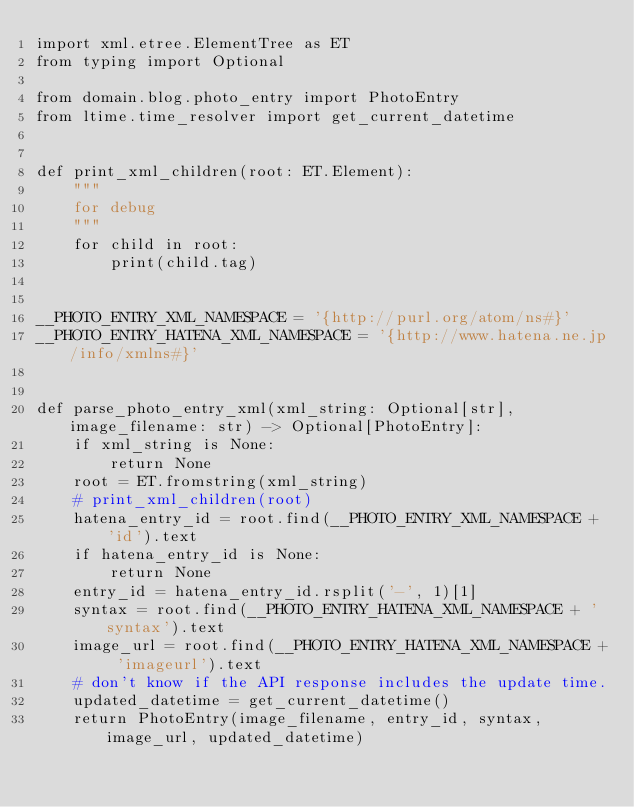Convert code to text. <code><loc_0><loc_0><loc_500><loc_500><_Python_>import xml.etree.ElementTree as ET
from typing import Optional

from domain.blog.photo_entry import PhotoEntry
from ltime.time_resolver import get_current_datetime


def print_xml_children(root: ET.Element):
    """
    for debug
    """
    for child in root:
        print(child.tag)


__PHOTO_ENTRY_XML_NAMESPACE = '{http://purl.org/atom/ns#}'
__PHOTO_ENTRY_HATENA_XML_NAMESPACE = '{http://www.hatena.ne.jp/info/xmlns#}'


def parse_photo_entry_xml(xml_string: Optional[str], image_filename: str) -> Optional[PhotoEntry]:
    if xml_string is None:
        return None
    root = ET.fromstring(xml_string)
    # print_xml_children(root)
    hatena_entry_id = root.find(__PHOTO_ENTRY_XML_NAMESPACE + 'id').text
    if hatena_entry_id is None:
        return None
    entry_id = hatena_entry_id.rsplit('-', 1)[1]
    syntax = root.find(__PHOTO_ENTRY_HATENA_XML_NAMESPACE + 'syntax').text
    image_url = root.find(__PHOTO_ENTRY_HATENA_XML_NAMESPACE + 'imageurl').text
    # don't know if the API response includes the update time.
    updated_datetime = get_current_datetime()
    return PhotoEntry(image_filename, entry_id, syntax, image_url, updated_datetime)
</code> 